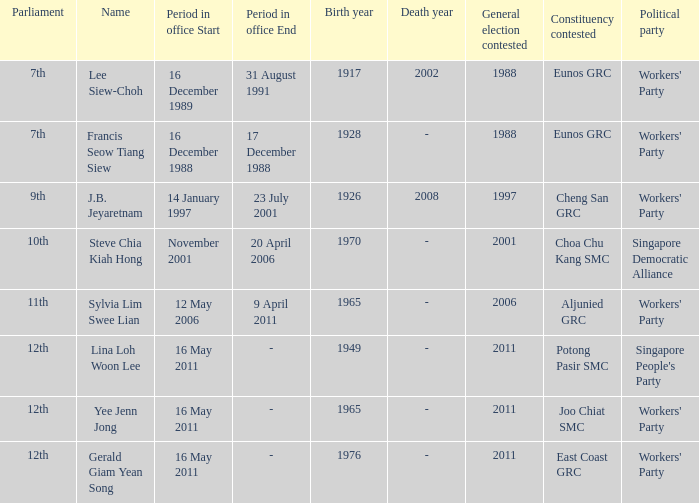What is the name of the parliament associated with lina loh woon lee? 12th. 